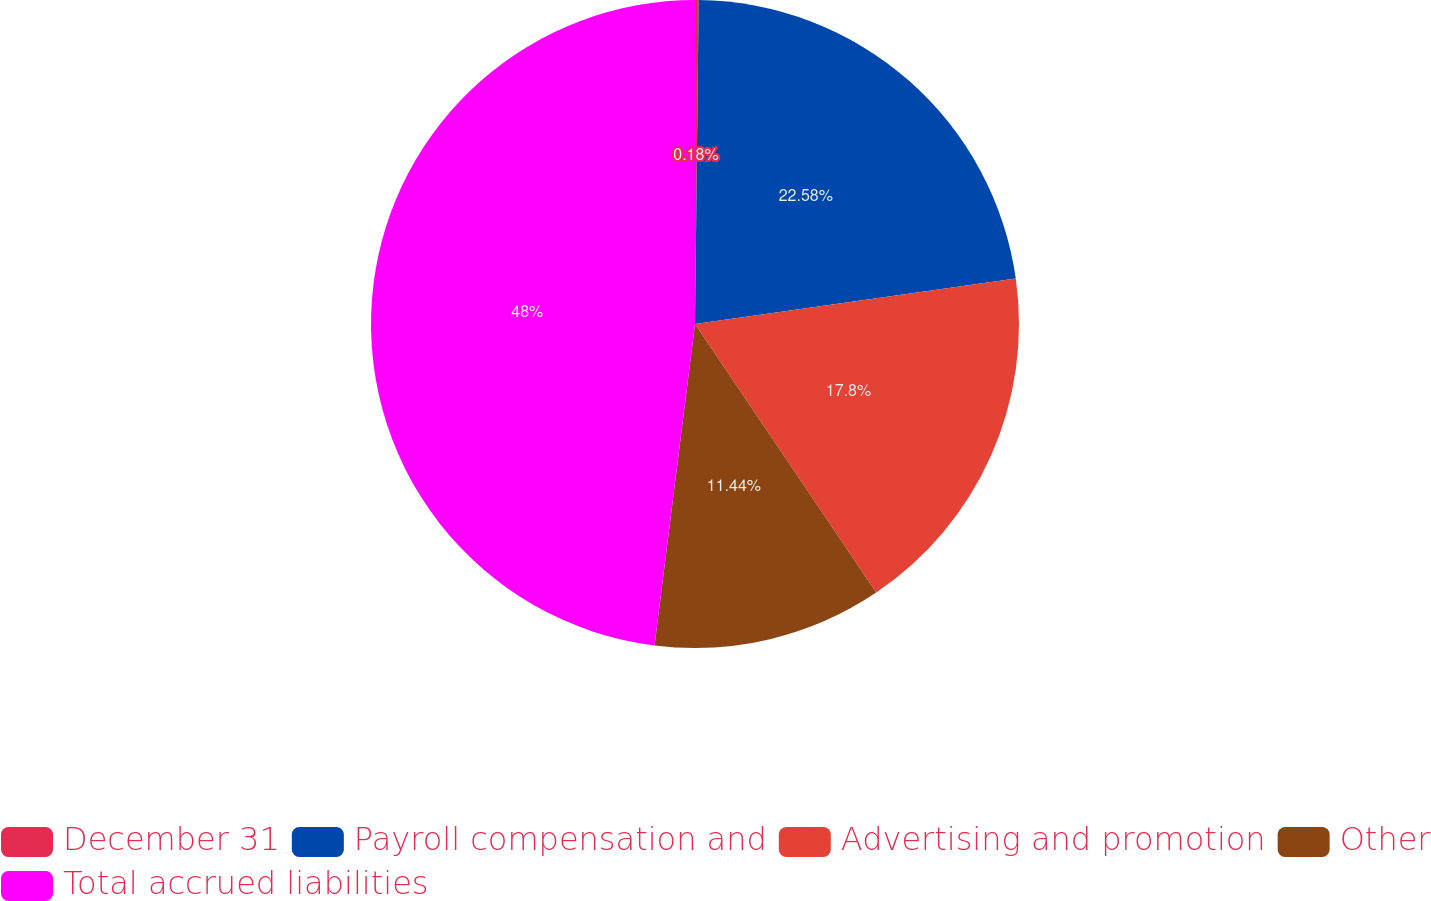Convert chart. <chart><loc_0><loc_0><loc_500><loc_500><pie_chart><fcel>December 31<fcel>Payroll compensation and<fcel>Advertising and promotion<fcel>Other<fcel>Total accrued liabilities<nl><fcel>0.18%<fcel>22.58%<fcel>17.8%<fcel>11.44%<fcel>48.01%<nl></chart> 